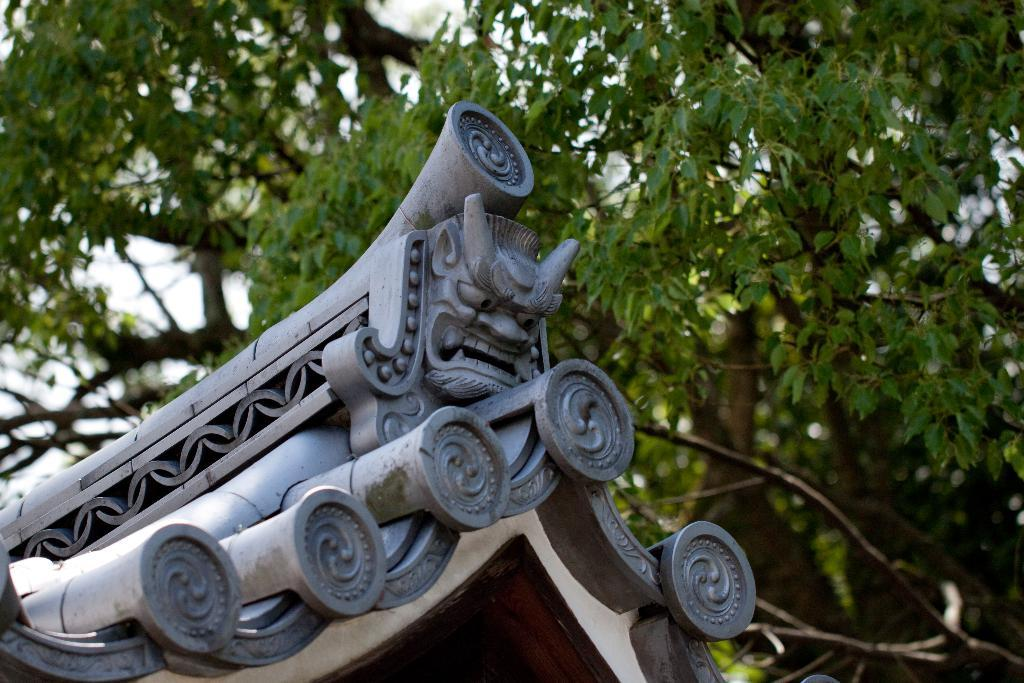What type of structure is present in the image? The image contains a roof. What can be seen in the background of the image? There are trees visible in the background of the image. What story is being told by the angry sea in the image? There is no sea or anger present in the image; it only contains a roof and trees in the background. 